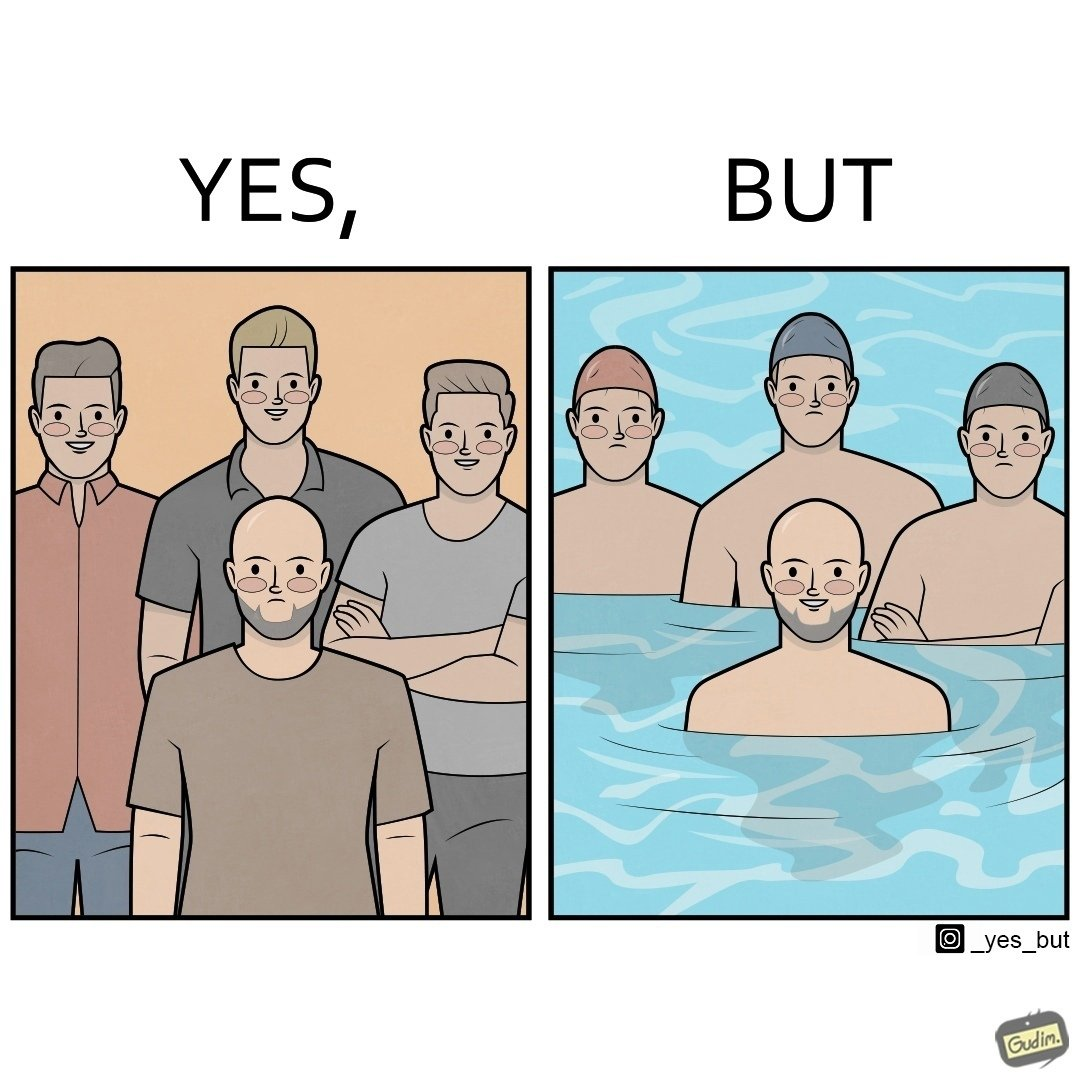Describe the satirical element in this image. The image is ironical, as person without hair is sad in a normal situation due to the absence of hair, unlike other people with hair. However, in a swimming pool, people with hair have to wear swimming caps, which is uncomfortable, while the person without hair does not need a cap, and is thus, happy in this situation. 